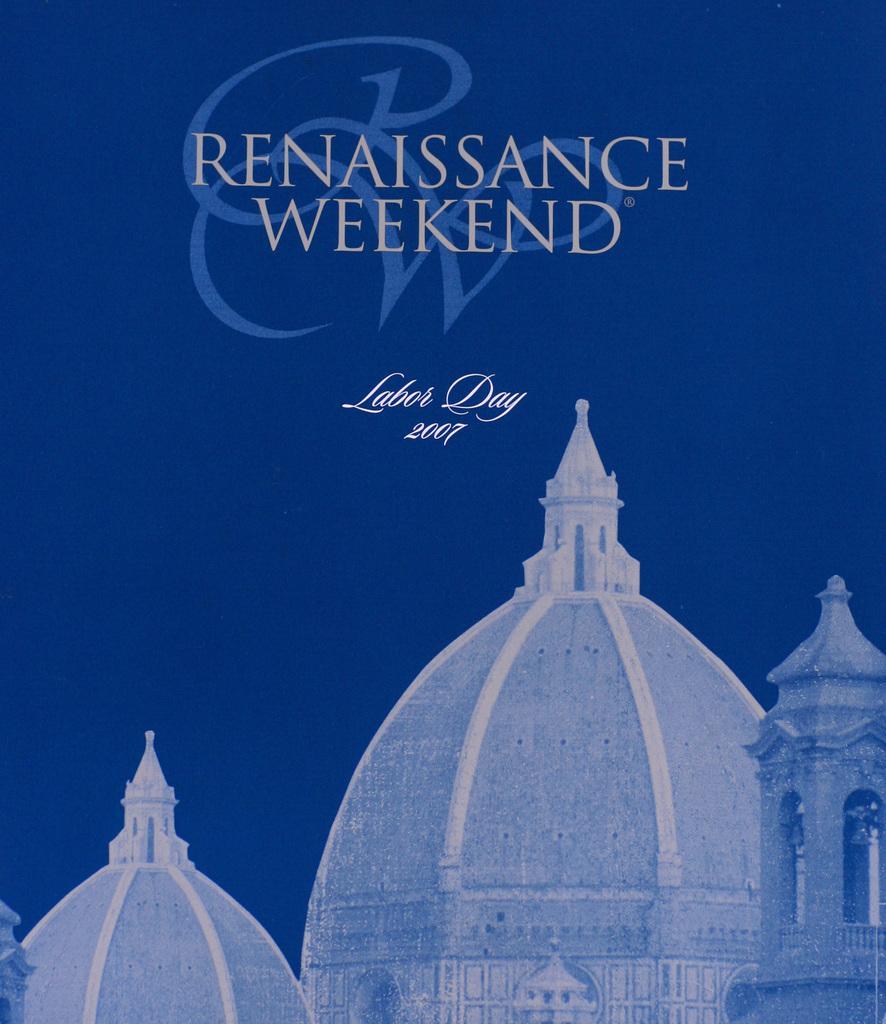Describe this image in one or two sentences. In this picture I can observe domes. I can observe text in the top and middle of the picture. The background is in blue color. 